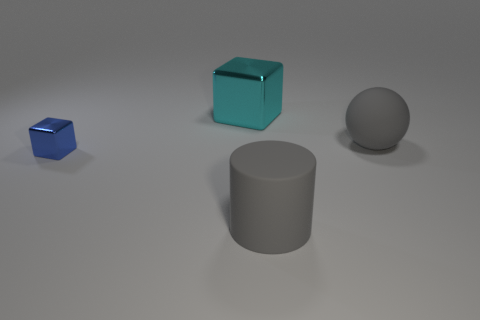How many balls are metal objects or large gray rubber objects?
Provide a succinct answer. 1. What material is the cylinder that is the same color as the rubber sphere?
Ensure brevity in your answer.  Rubber. Is the number of gray spheres on the left side of the large cyan metallic object less than the number of small cubes that are in front of the blue thing?
Your response must be concise. No. What number of things are big objects that are in front of the large cyan thing or green rubber things?
Keep it short and to the point. 2. There is a metal thing that is to the left of the metal object behind the big ball; what shape is it?
Provide a succinct answer. Cube. Is there a shiny object of the same size as the ball?
Offer a very short reply. Yes. Is the number of big red metallic blocks greater than the number of blue metallic things?
Provide a short and direct response. No. Is the size of the shiny block that is in front of the large cyan metallic block the same as the thing that is right of the gray rubber cylinder?
Provide a short and direct response. No. How many big things are in front of the large cyan block and behind the large gray cylinder?
Offer a terse response. 1. The other metallic object that is the same shape as the small blue metal thing is what color?
Provide a succinct answer. Cyan. 